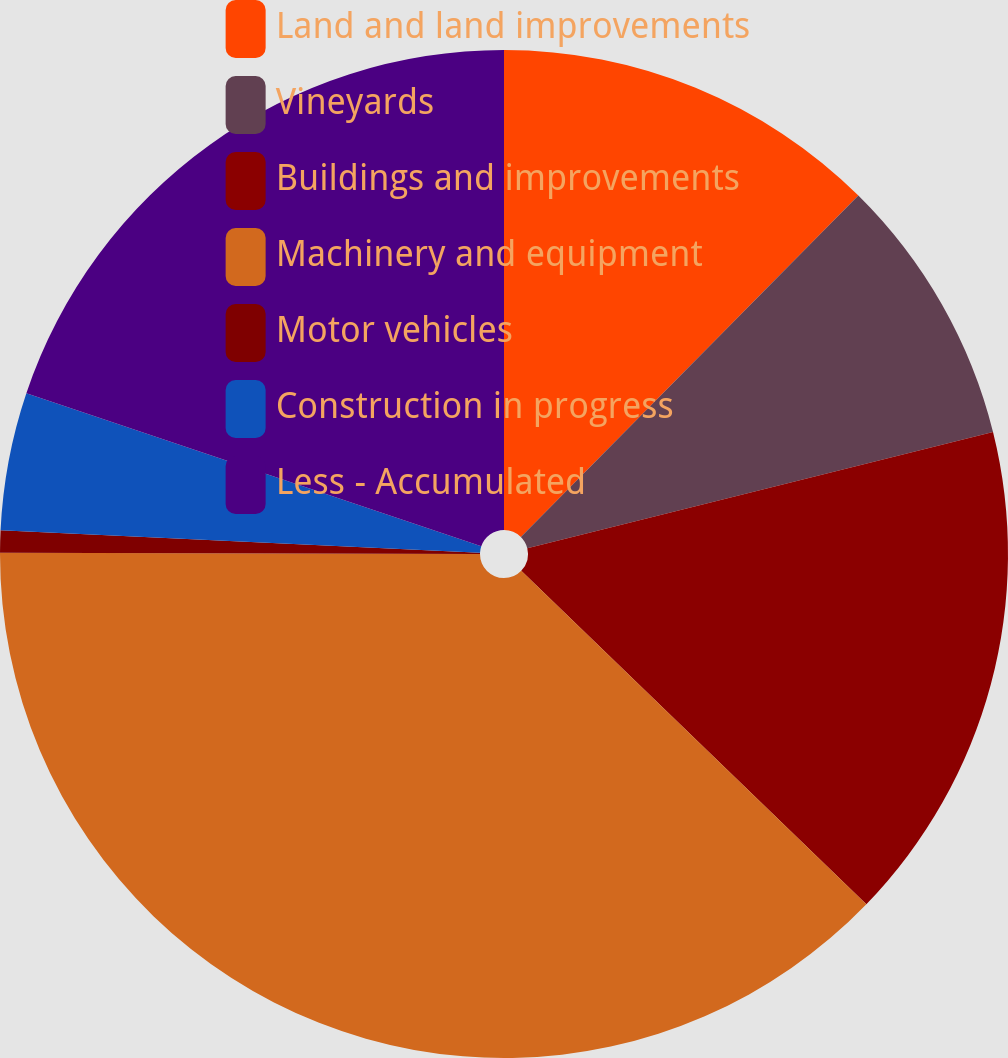Convert chart to OTSL. <chart><loc_0><loc_0><loc_500><loc_500><pie_chart><fcel>Land and land improvements<fcel>Vineyards<fcel>Buildings and improvements<fcel>Machinery and equipment<fcel>Motor vehicles<fcel>Construction in progress<fcel>Less - Accumulated<nl><fcel>12.41%<fcel>8.7%<fcel>16.12%<fcel>37.81%<fcel>0.71%<fcel>4.42%<fcel>19.83%<nl></chart> 